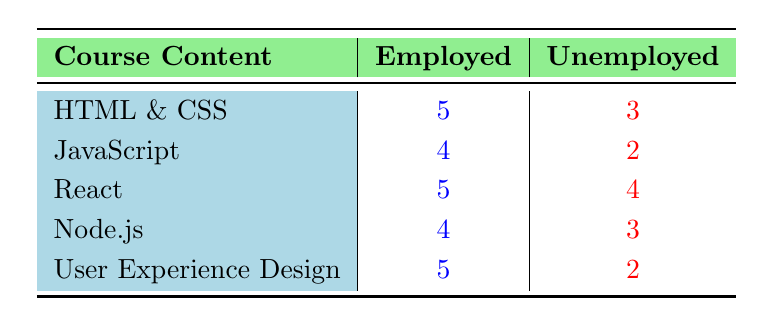What is the highest satisfaction rating for employed graduates? The highest satisfaction rating among employed graduates can be found by looking at the "Employed" column. The maximum value is 5, which appears for the course contents "HTML & CSS," "React," and "User Experience Design."
Answer: 5 What is the lowest satisfaction rating for unemployed graduates? The lowest satisfaction rating among unemployed graduates is found by scanning the "Unemployed" column. The minimum value is 2, which appears for the course contents "User Experience Design" and "JavaScript."
Answer: 2 How many courses received a satisfaction rating of 4 or higher from employed graduates? First, we look at the "Employed" column and count the courses with ratings of 4 or higher. The courses "HTML & CSS," "JavaScript," "React," "Node.js," and "User Experience Design" meet this criterion, giving a total count of 5 courses.
Answer: 5 Is there a difference between the satisfaction ratings of the same course content for employed vs. unemployed graduates? To answer this, we can compare the ratings for each course. For example, "HTML & CSS" received 5 for employed and 3 for unemployed (difference of 2), "JavaScript" received 4 and 2 (difference of 2), and so forth. Most courses show a difference in ratings, indicating varied experiences based on employment status.
Answer: Yes What is the average satisfaction rating for unemployed graduates? To find the average, we sum the satisfaction ratings of unemployed graduates: (3 + 2 + 4 + 3 + 2) = 14. Then, we divide by the number of courses (5). So, 14/5 = 2.8.
Answer: 2.8 How does the satisfaction rating for "React" compare between employed and unemployed graduates? The satisfaction rating for "React" is 5 for employed graduates and 4 for unemployed graduates. We can see that employed graduates rated it higher by 1 point.
Answer: 1 point difference Which course had the highest satisfaction rating difference between employed and unemployed graduates? We will calculate the difference for each course: "HTML & CSS" (5 - 3 = 2), "JavaScript" (4 - 2 = 2), "React" (5 - 4 = 1), "Node.js" (4 - 3 = 1), and "User Experience Design" (5 - 2 = 3). The highest difference of 3 is for "User Experience Design."
Answer: User Experience Design Are all courses rated higher by employed graduates than unemployed graduates? We compare each course's ratings. "HTML & CSS," "React," "Node.js," and "User Experience Design" all have higher ratings for employed, but "JavaScript" is rated higher for employed (4) vs unemployed (2), maintaining the trend. Therefore, all courses are rated higher by employed graduates.
Answer: Yes 